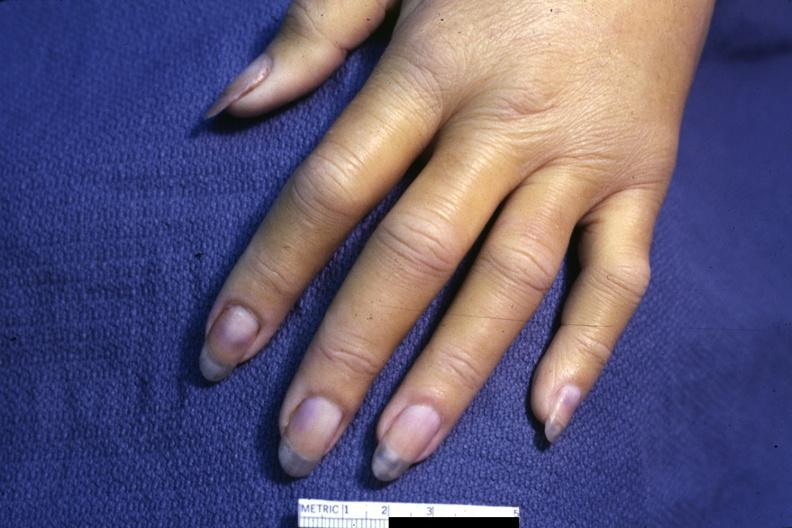s parathyroid present?
Answer the question using a single word or phrase. No 